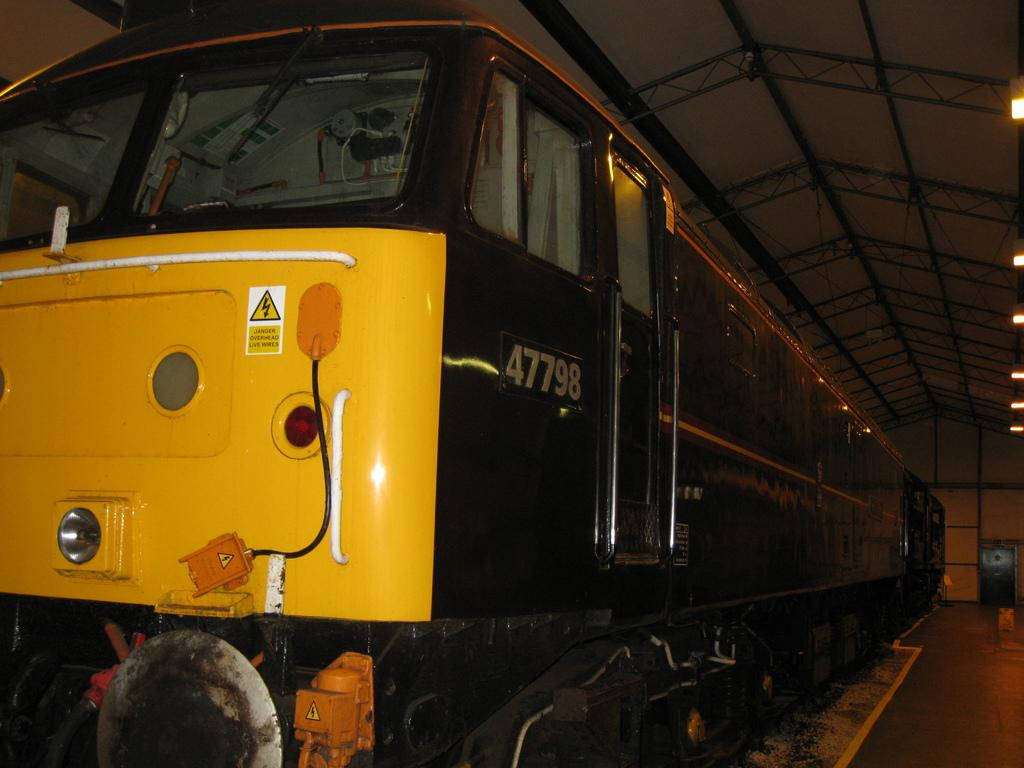What is the main subject on the left side of the image? There is a train engine on the left side of the image. What structure can be seen at the top of the image? There appears to be a shed at the top of the image. What can be seen on the right side of the image? There are lights visible on the right side of the image. What type of competition is taking place in the image? There is no competition present in the image. What interests can be observed in the image? The image does not depict any specific interests or hobbies. 